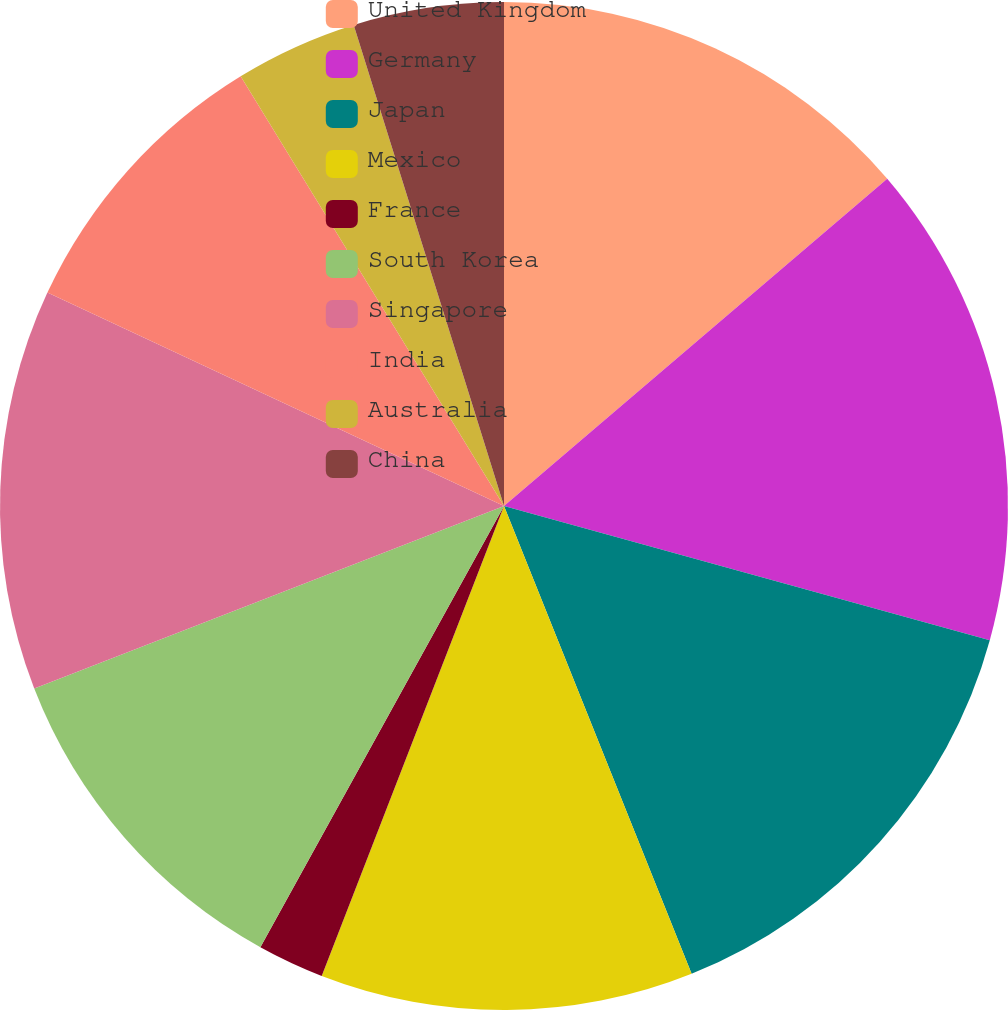<chart> <loc_0><loc_0><loc_500><loc_500><pie_chart><fcel>United Kingdom<fcel>Germany<fcel>Japan<fcel>Mexico<fcel>France<fcel>South Korea<fcel>Singapore<fcel>India<fcel>Australia<fcel>China<nl><fcel>13.75%<fcel>15.54%<fcel>14.64%<fcel>11.96%<fcel>2.14%<fcel>11.07%<fcel>12.86%<fcel>9.29%<fcel>3.93%<fcel>4.82%<nl></chart> 